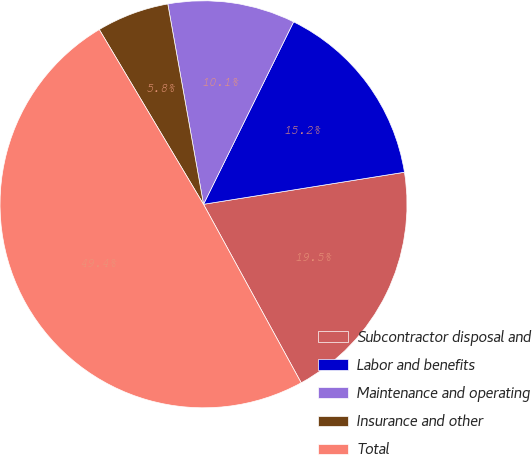Convert chart. <chart><loc_0><loc_0><loc_500><loc_500><pie_chart><fcel>Subcontractor disposal and<fcel>Labor and benefits<fcel>Maintenance and operating<fcel>Insurance and other<fcel>Total<nl><fcel>19.55%<fcel>15.18%<fcel>10.11%<fcel>5.75%<fcel>49.41%<nl></chart> 